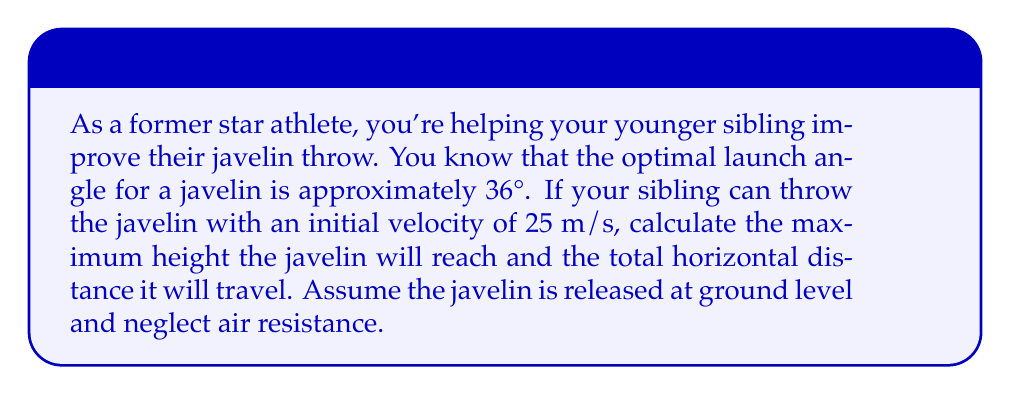Solve this math problem. Let's approach this step-by-step using the equations of projectile motion:

1) First, let's define our variables:
   $v_0 = 25$ m/s (initial velocity)
   $\theta = 36°$ (launch angle)
   $g = 9.8$ m/s² (acceleration due to gravity)

2) We can break down the initial velocity into its horizontal and vertical components:
   $v_{0x} = v_0 \cos(\theta) = 25 \cos(36°) = 20.21$ m/s
   $v_{0y} = v_0 \sin(\theta) = 25 \sin(36°) = 14.68$ m/s

3) To find the maximum height, we use the equation:
   $$h_{max} = \frac{v_{0y}^2}{2g}$$
   
   Substituting our values:
   $$h_{max} = \frac{(14.68)^2}{2(9.8)} = 11.00$$ m

4) For the total horizontal distance (range), we use the equation:
   $$R = \frac{v_0^2 \sin(2\theta)}{g}$$
   
   Substituting our values:
   $$R = \frac{25^2 \sin(2(36°))}{9.8} = 53.03$$ m

[asy]
import geometry;

size(200,150);

pair O=(0,0);
pair A=(53.03,0);
pair H=(26.515,11);

draw(O--A,Arrow);
draw(O--H--A,dashed);

label("0 m", O, SW);
label("53.03 m", A, SE);
label("11 m", H, N);

draw(arc(O,5,0,36),Arrow);
label("36°", (3,3), NE);

[/asy]

This diagram illustrates the trajectory of the javelin, showing the maximum height and the range.
Answer: The javelin will reach a maximum height of 11.00 m and travel a total horizontal distance of 53.03 m. 